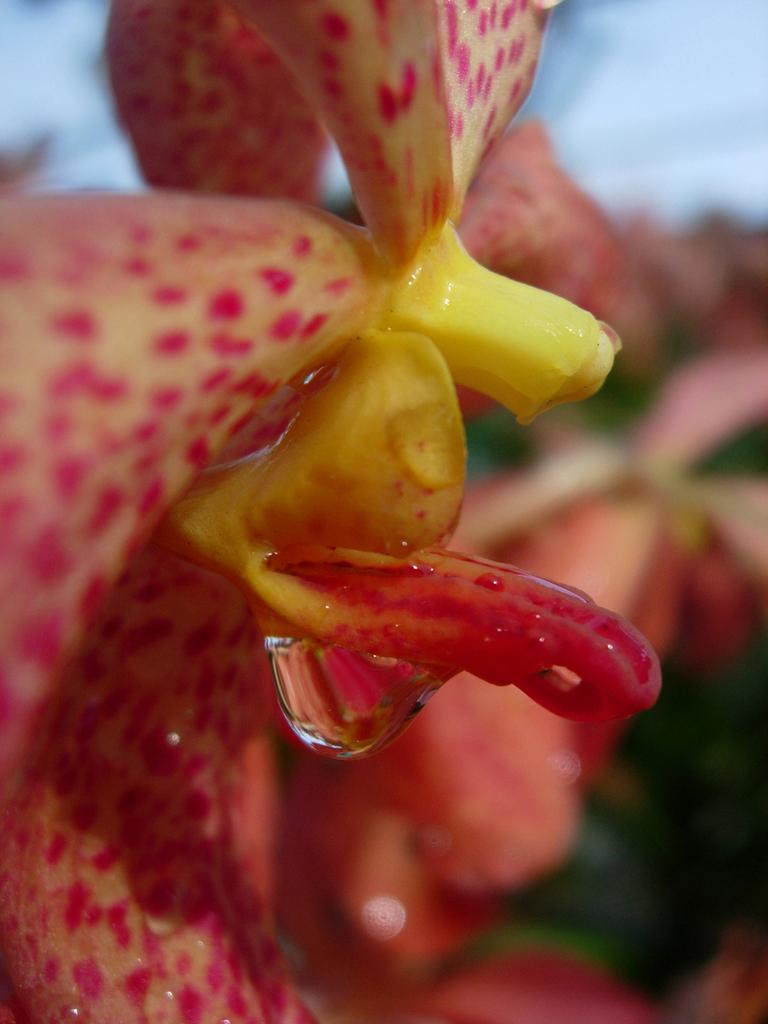What is the main subject of the image? There is a flower in the image. Can you describe any specific details about the flower? Yes, there is a water drop on the flower. How would you describe the background of the image? The background of the image is blurred. What type of flag is visible on the stem of the flower in the image? There is no flag present on the stem of the flower in the image. Can you describe the facial expression of the flower in the image? Flowers do not have facial expressions, so it is not possible to describe a smile on the flower in the image. 